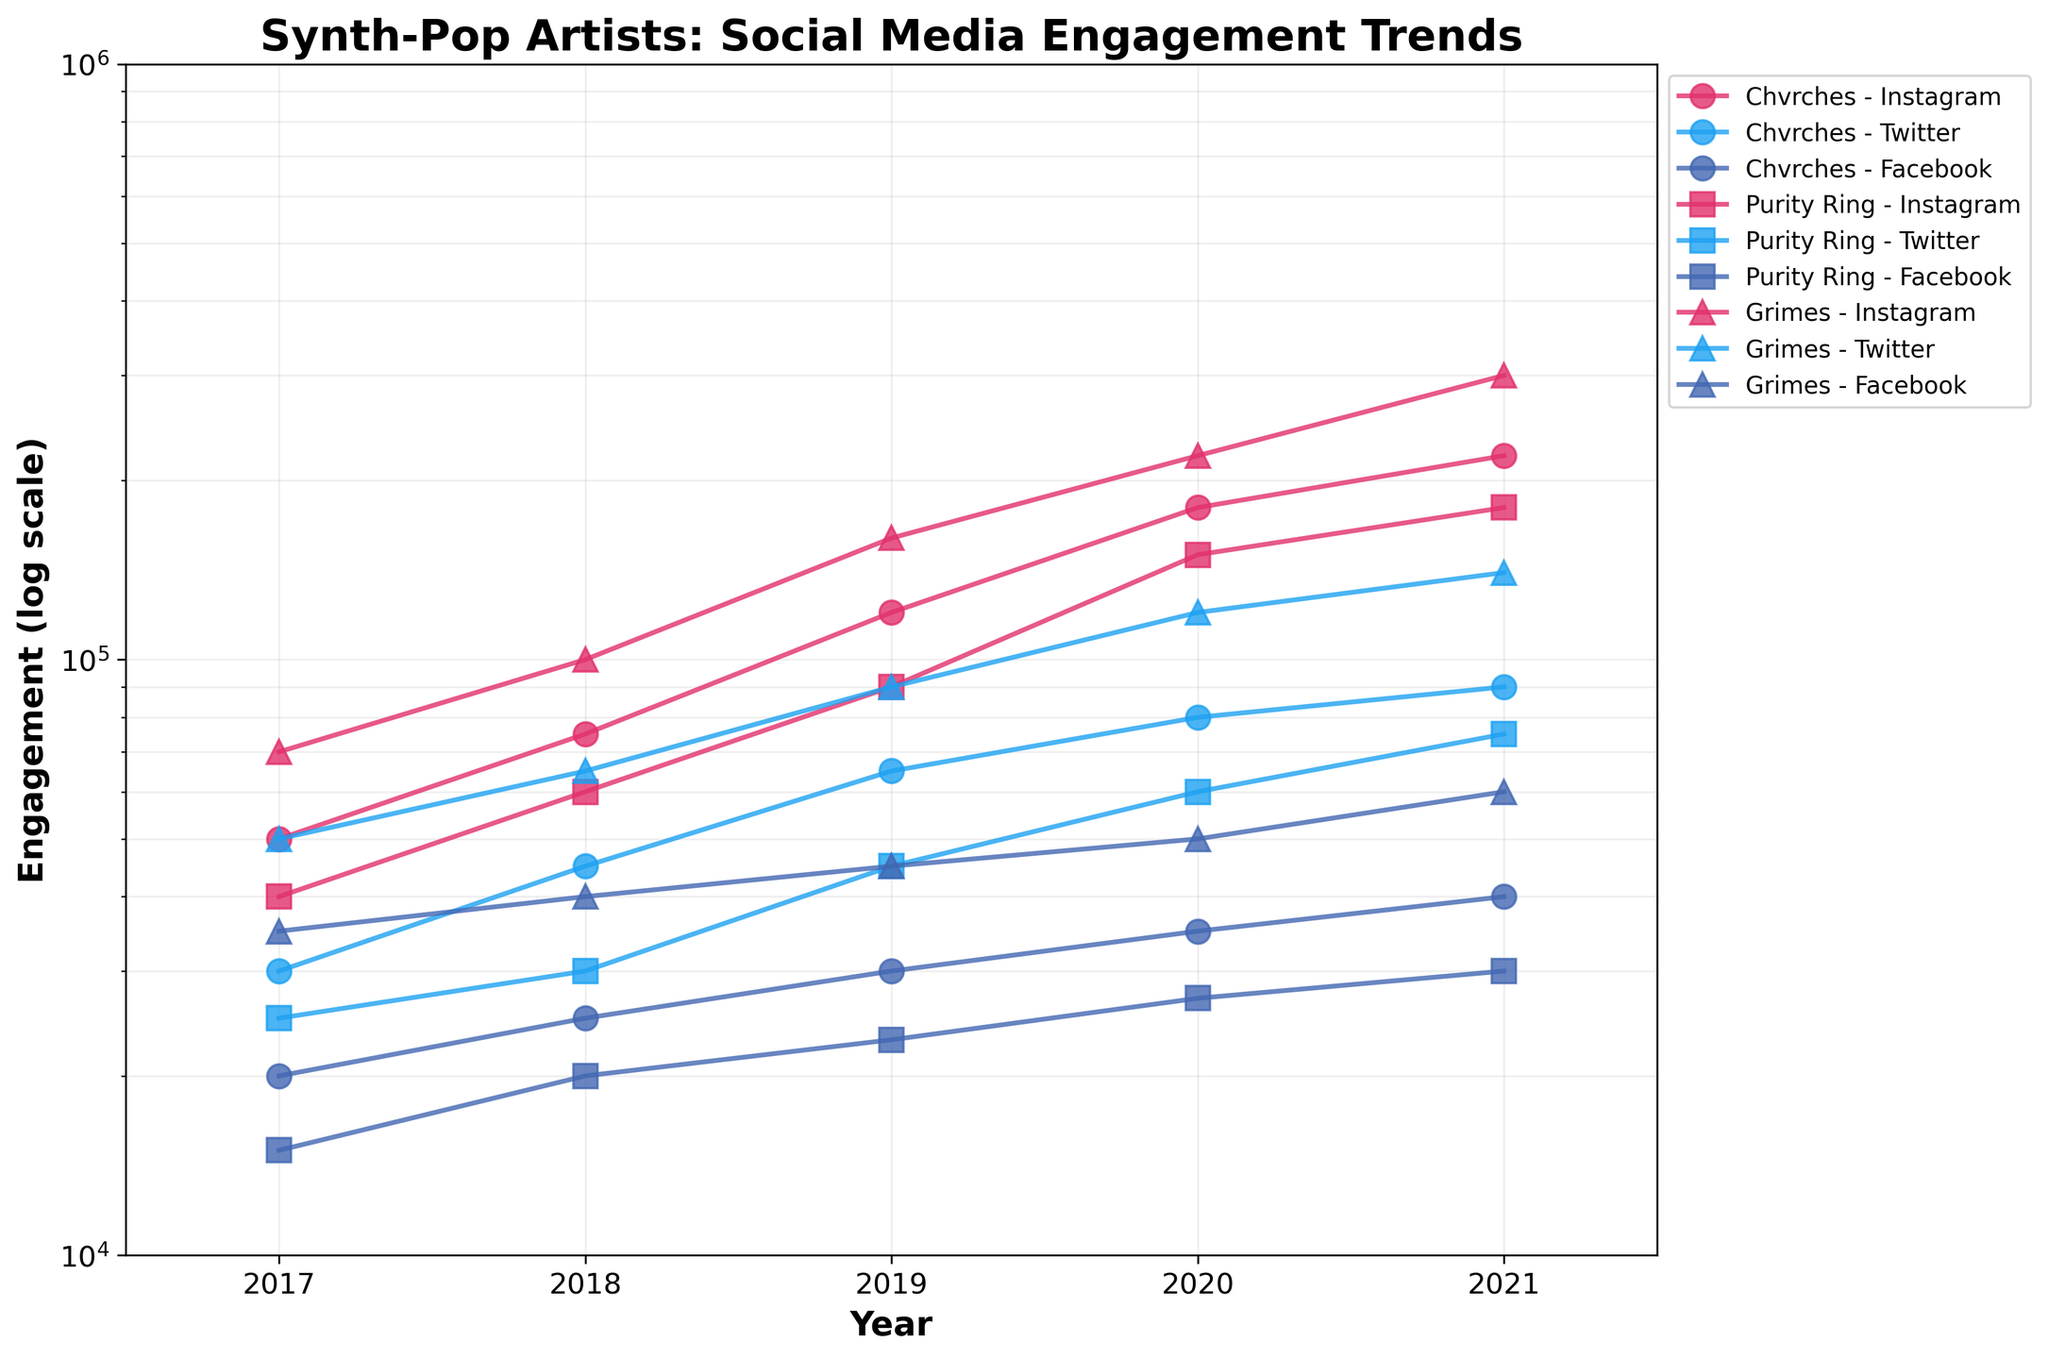How many different platforms are tracked in the figure? The figure displays engagement metrics for three distinct social media platforms, as indicated by the different colors used in the plot.
Answer: Three Which artist had the highest engagement on Instagram in 2021? Looking at the highest y-axis value for Instagram in 2021, the figure shows that Grimes had the highest engagement.
Answer: Grimes How did Chvrches' Twitter engagement change from 2018 to 2019? To determine the change, look at the engagement values for Chvrches on Twitter in 2018 and 2019. In 2018, it was 45,000, and in 2019, it was 65,000. The change is calculated as 65,000 - 45,000 = 20,000.
Answer: Increased by 20,000 Which platform showed the least overall engagement across all artists and years? By comparing the y-axis values across all platforms throughout the years, Facebook consistently shows the lowest engagement levels for all artists.
Answer: Facebook What is the engagement trend on Instagram for Purity Ring from 2017 to 2021? The trend can be observed by plotting the Instagram engagement data for Purity Ring from 2017 (40,000) to 2021 (180,000). The values show a steady increase over the years.
Answer: Increasing In which year did Grimes see the biggest jump in Instagram engagement, and by how much? Observing the year-on-year changes in Instagram engagement for Grimes, the biggest jump appears between 2019 (160,000) and 2020 (220,000). The difference is 220,000 - 160,000 = 60,000.
Answer: 2020, 60,000 How does the engagement growth of Chvrches on Facebook compare to their growth on Instagram from 2017 to 2021? Calculate the difference in engagement for both platforms between these years. For Facebook: 40,000 - 20,000 = 20,000. For Instagram: 220,000 - 50,000 = 170,000. Comparatively, Instagram shows a much larger growth.
Answer: Instagram growth is much larger Which artist had the least Twitter engagement in 2021, and what was the value? By looking at the Twitter engagement values for 2021 for all artists, Purity Ring had the least engagement at 75,000.
Answer: Purity Ring, 75,000 What is the ratio of Grimes' Instagram engagement to her Facebook engagement in 2020? Divide Grimes' Instagram engagement in 2020 (220,000) by her Facebook engagement in the same year (50,000) to get the ratio. 220,000 / 50,000 = 4.4.
Answer: 4.4 